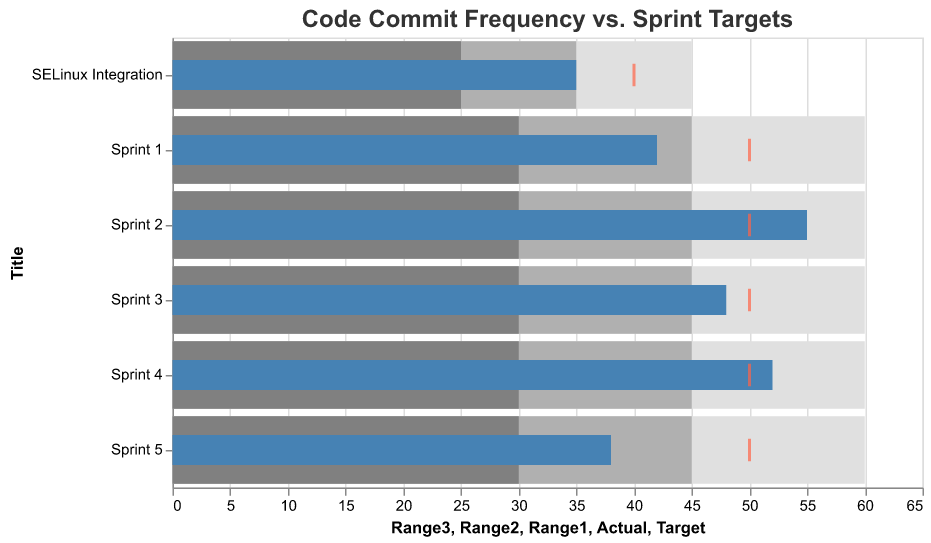What is the title of the figure? The title is displayed at the top of the figure and shows the overall topic it represents.
Answer: Code Commit Frequency vs. Sprint Targets What color represents the 'Actual' values in the bullet chart? Observing the different colors in the chart, the 'Actual' values are represented with the blue color bars.
Answer: Blue How many data points are there in total in the figure? The figure shows each data point labeled along the y-axis. Counting these labels gives us the total number of data points.
Answer: 6 Which sprint had the highest actual code commits, and how many? By comparing the 'Actual' values for each sprint, Sprint 2 has the highest number of actual code commits according to the blue bar representing 'Actual' values.
Answer: Sprint 2, 55 What is the actual number of code commits for Sprint 5, and how does it compare to its target? The 'Actual' value for Sprint 5 is represented by a blue bar, and the target is shown by a red tick mark. Comparing these two values gives us Sprint 5's performance.
Answer: Actual: 38, Target: 50 What is the range defined for 'Range1', 'Range2', and 'Range3' for the SELinux Integration sprint? The ranges are represented by bars with different shades of gray in the figure. Observing these values for the SELinux Integration sprint gives us the defined ranges.
Answer: Range1: 25, Range2: 35, Range3: 45 How many sprints had actual code commits that exceeded their target? Evaluate the 'Actual' value and the 'Target' for each sprint. If the 'Actual' value shown by the blue bar exceeds the red target tick mark, it counts.
Answer: 2 (Sprint 2 and Sprint 4) What is the difference in actual code commits between Sprint 1 and Sprint 5? Subtract the 'Actual' value of Sprint 5 from Sprint 1, which are shown as blue bars. Sprint 1 had 42, and Sprint 5 had 38. The difference is 42 - 38 = 4.
Answer: 4 How did the SELinux Integration sprint perform compared to its target code commits? The 'Actual' value and the 'Target' for the SELinux Integration sprint are represented by the blue bar and the red tick mark, respectively. Compare these values.
Answer: Below target by 5 commits Which range has the smallest width for Sprint 3, and what is that width? Compare the widths of the ranges 'Range1', 'Range2', and 'Range3', defined by gray bars for Sprint 3. Calculate the width by subtracting the smallest value from the largest value. For Sprint 3, Range1: 30-45, Range2: 45-60, Range3: 30-60.
Answer: Range1, width 15 (45 - 30) Which sprint had the closest actual code commits to the target, and what is the difference? Calculate the absolute difference between the 'Actual' (blue bar) and 'Target' (red tick mark) for each sprint and find the smallest difference.
Answer: Sprint 3, difference 2 Which sprint had the least actual code commits, and what might be a potential reason based on the ranges? Compare 'Actual' values for all sprints and observe that Sprint 5 has the lowest value of 38. Looking at the ranges might help understand the target difficulty.
Answer: Sprint 5, possibly due to a tougher target range 